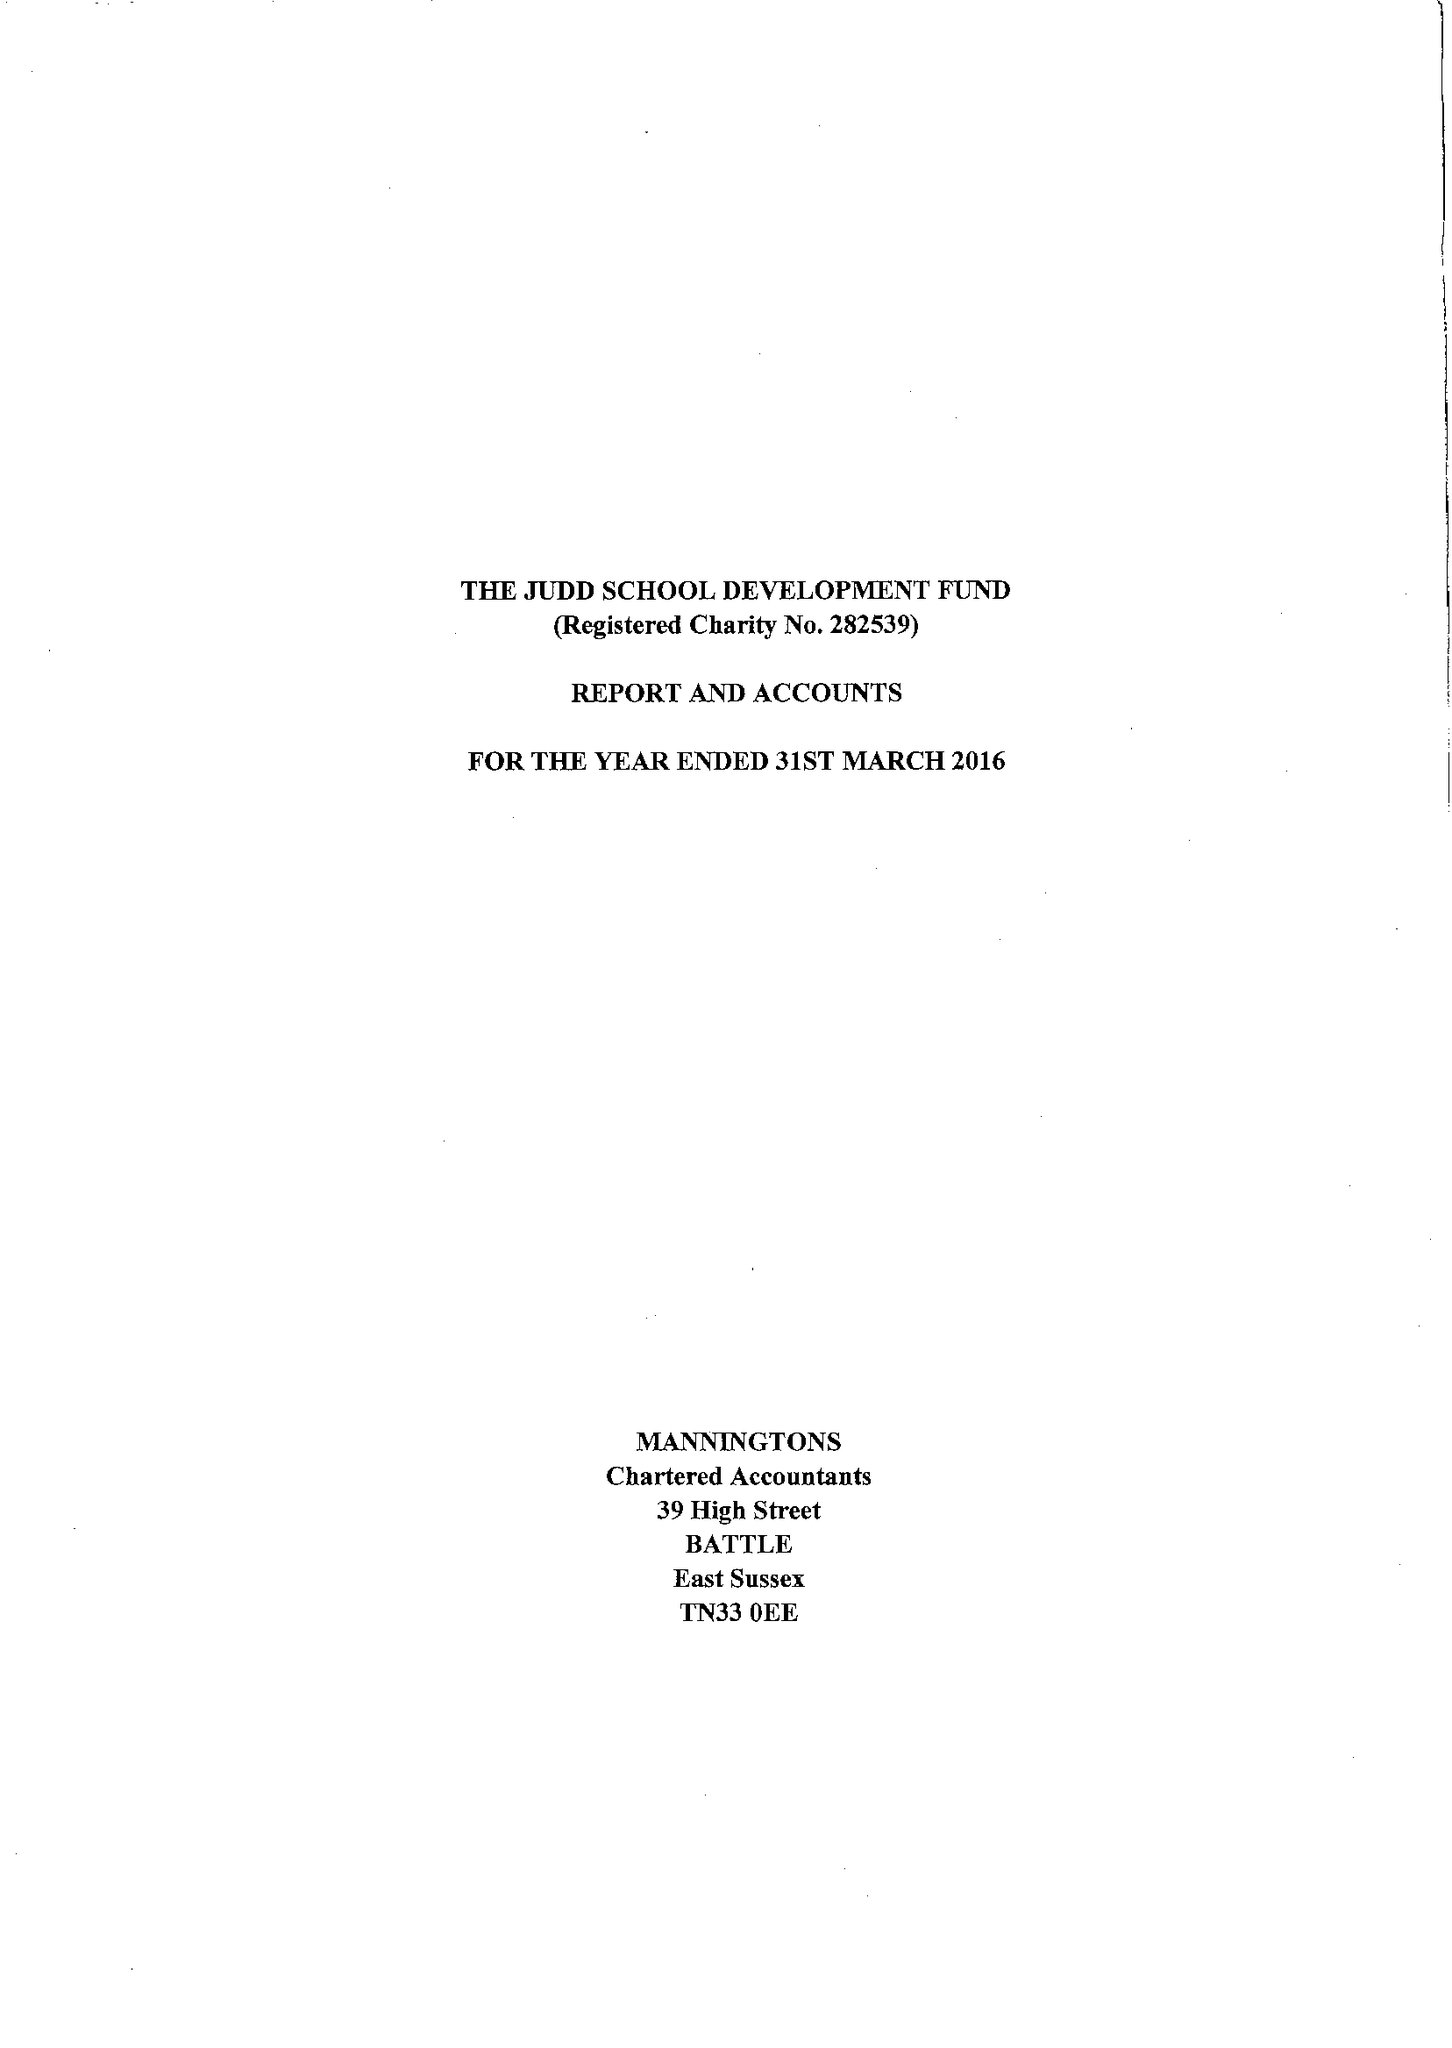What is the value for the address__street_line?
Answer the question using a single word or phrase. 8 DOWGATE HILL 